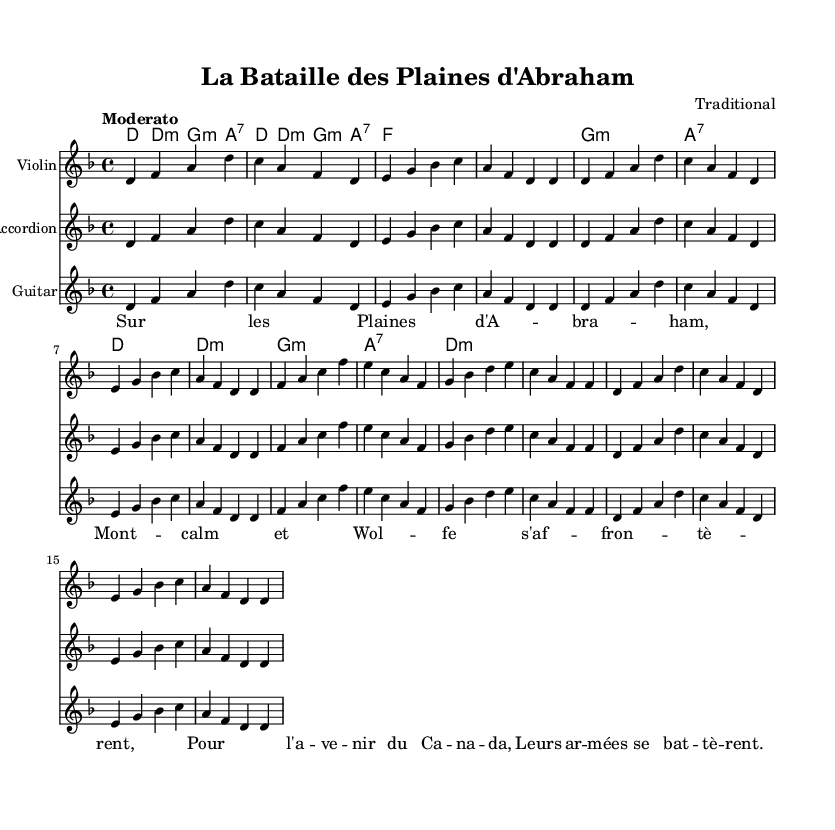What is the key signature of this music? The key signature is D minor, indicated by one flat (B flat).
Answer: D minor What is the time signature of this music? The time signature is 4/4, which is shown at the beginning of the sheet music.
Answer: 4/4 What is the tempo marking for this piece? The tempo marking is "Moderato," indicating a moderate speed.
Answer: Moderato How many measures are there in the melody section? There are 16 measures in the melody section, as determined by counting each distinct bar line used to separate the phrases.
Answer: 16 Which historical event does the song recount? The song recounts the Battle of the Plains of Abraham, which is evident from the title specified at the beginning.
Answer: Battle of the Plains of Abraham What instruments are indicated in the score? The score lists Violin, Accordion, and Guitar as the instruments to be used.
Answer: Violin, Accordion, Guitar What type of song is "La Bataille des Plaines d'Abraham"? This song is a traditional historical song that recounts significant events in Quebec's past, emphasizing the cultural heritage of the region.
Answer: Traditional historical song 